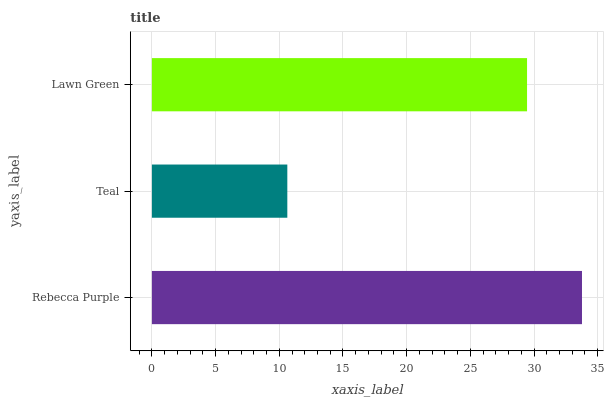Is Teal the minimum?
Answer yes or no. Yes. Is Rebecca Purple the maximum?
Answer yes or no. Yes. Is Lawn Green the minimum?
Answer yes or no. No. Is Lawn Green the maximum?
Answer yes or no. No. Is Lawn Green greater than Teal?
Answer yes or no. Yes. Is Teal less than Lawn Green?
Answer yes or no. Yes. Is Teal greater than Lawn Green?
Answer yes or no. No. Is Lawn Green less than Teal?
Answer yes or no. No. Is Lawn Green the high median?
Answer yes or no. Yes. Is Lawn Green the low median?
Answer yes or no. Yes. Is Teal the high median?
Answer yes or no. No. Is Rebecca Purple the low median?
Answer yes or no. No. 